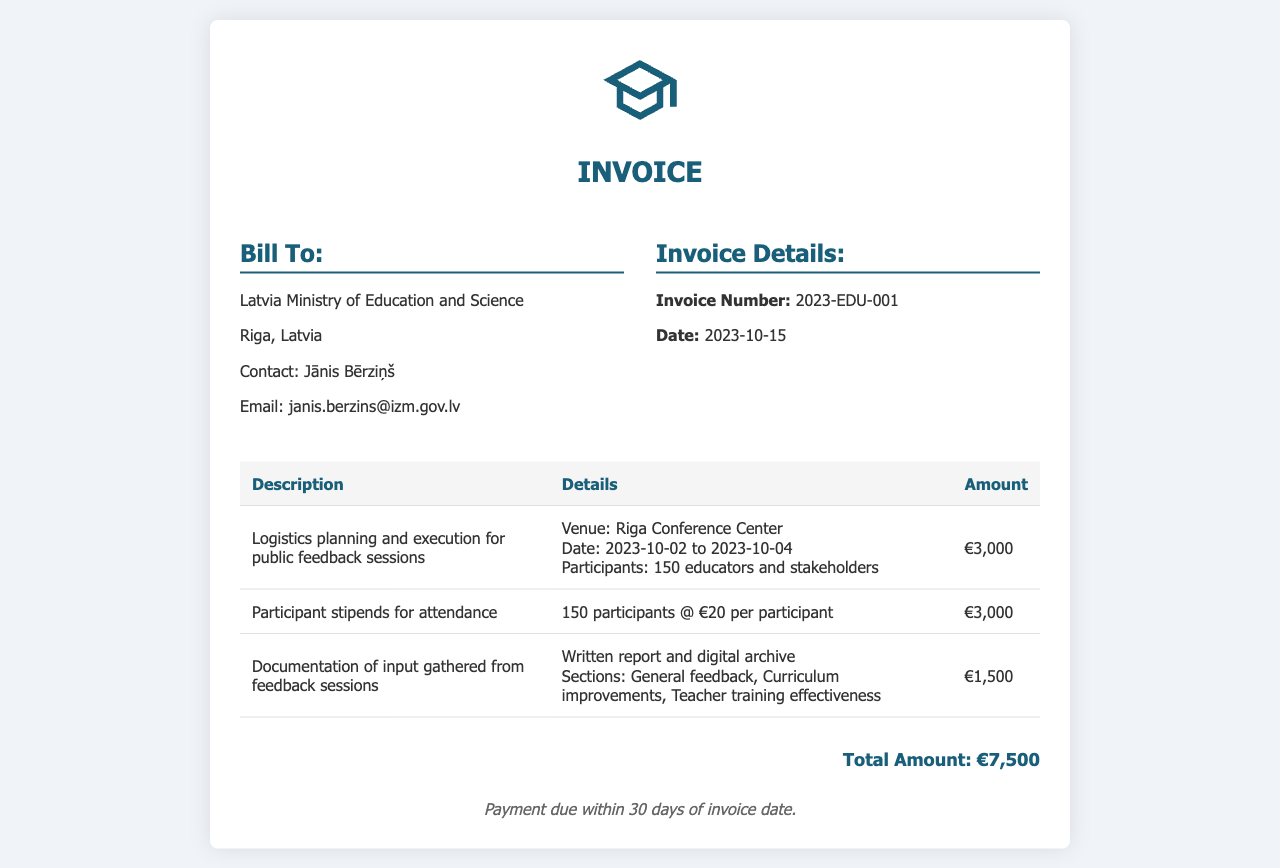What is the invoice number? The invoice number is clearly stated in the document for identification purposes.
Answer: 2023-EDU-001 What is the total amount due? The total amount is the final figure listed at the bottom of the invoice.
Answer: €7,500 Who is the contact person for the invoice? The contact person is mentioned in the billing section of the invoice.
Answer: Jānis Bērziņš What were the dates of the feedback sessions? The dates are mentioned in the logistics details of the invoice.
Answer: 2023-10-02 to 2023-10-04 How many participants attended the sessions? The number of participants is specified in the logistics section of the invoice.
Answer: 150 What is the amount allocated for participant stipends? The stipends amount is detailed under the corresponding item in the invoice.
Answer: €3,000 What type of document was generated from the feedback sessions? This is indicated in the description of the documentation of input gathered.
Answer: Written report and digital archive When is the payment due? The payment terms are explicitly stated at the bottom of the invoice.
Answer: Within 30 days of invoice date 